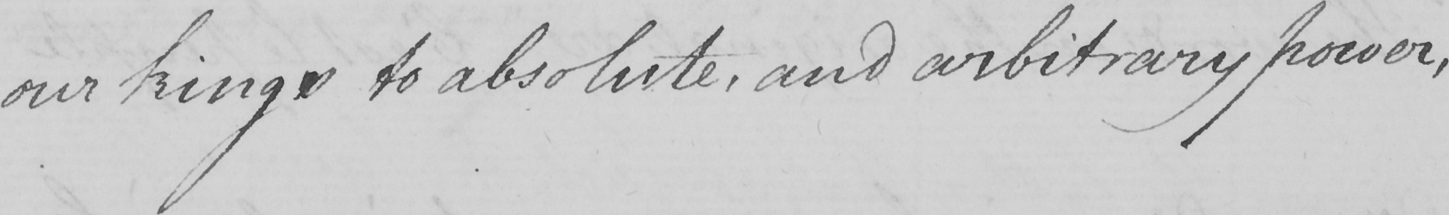Can you tell me what this handwritten text says? our kings to absolute , and arbitrary power , 